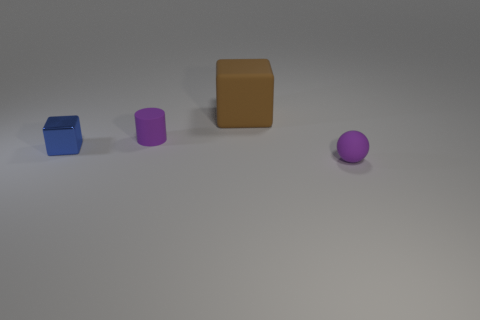Add 3 blue blocks. How many objects exist? 7 Subtract all cylinders. How many objects are left? 3 Subtract all tiny yellow balls. Subtract all small cubes. How many objects are left? 3 Add 1 tiny blue objects. How many tiny blue objects are left? 2 Add 4 rubber blocks. How many rubber blocks exist? 5 Subtract 0 red balls. How many objects are left? 4 Subtract all green cylinders. Subtract all cyan blocks. How many cylinders are left? 1 